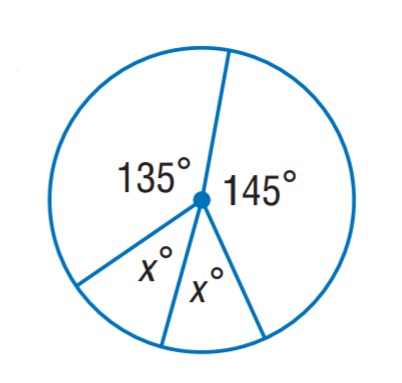Question: Find x.
Choices:
A. 10
B. 20
C. 30
D. 40
Answer with the letter. Answer: D 